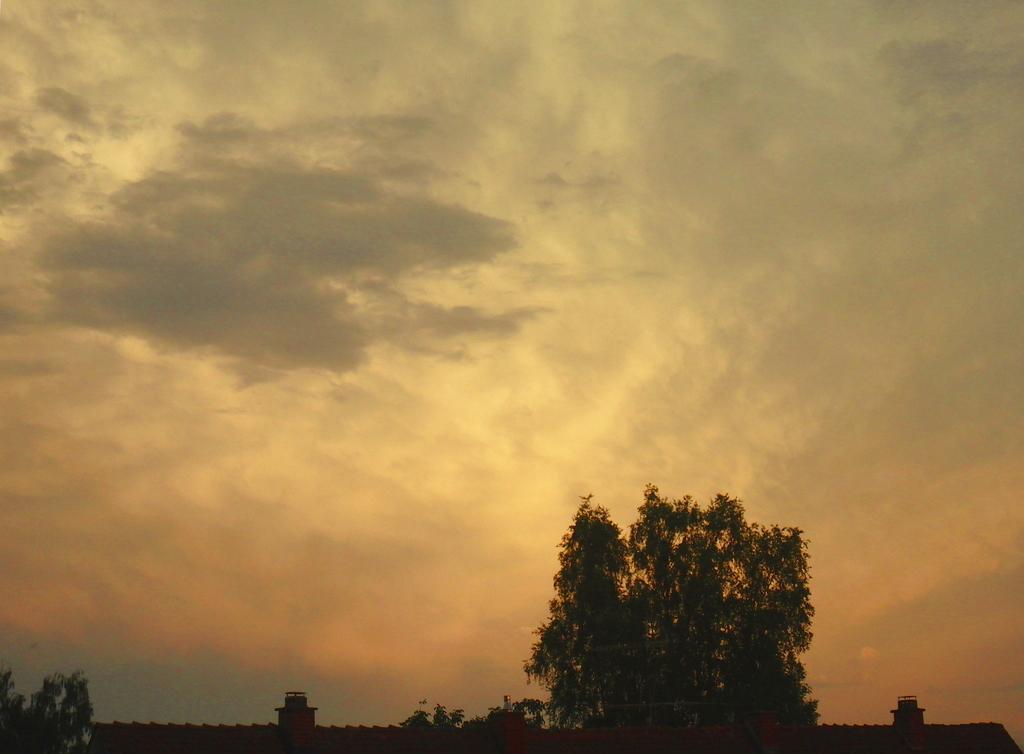How would you summarize this image in a sentence or two? In this picture we can see some trees and clouded sky. 